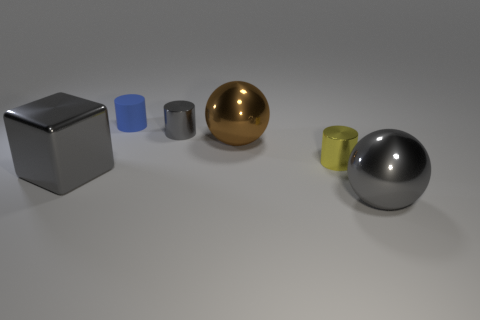What shape is the yellow thing that is the same material as the large cube?
Your answer should be compact. Cylinder. Is the number of small gray cylinders behind the large gray sphere less than the number of big brown metal things that are to the right of the big brown thing?
Provide a succinct answer. No. How many tiny objects are either yellow metal objects or matte cylinders?
Provide a short and direct response. 2. There is a gray metal object in front of the large cube; is its shape the same as the gray shiny thing that is behind the yellow cylinder?
Your response must be concise. No. There is a shiny sphere that is behind the big shiny thing that is left of the blue thing on the left side of the brown metal thing; what is its size?
Your response must be concise. Large. How big is the metallic thing that is on the left side of the small blue rubber object?
Ensure brevity in your answer.  Large. There is a thing behind the tiny gray metallic object; what is its material?
Make the answer very short. Rubber. How many yellow objects are large matte blocks or tiny cylinders?
Offer a very short reply. 1. Is the material of the small blue object the same as the large object that is on the right side of the brown ball?
Your answer should be very brief. No. Are there the same number of yellow things left of the metal cube and cylinders left of the rubber cylinder?
Your answer should be very brief. Yes. 